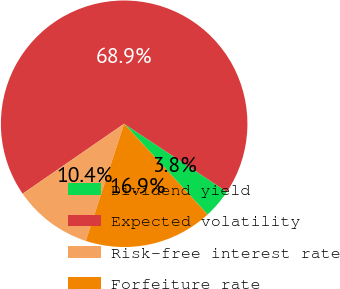<chart> <loc_0><loc_0><loc_500><loc_500><pie_chart><fcel>Dividend yield<fcel>Expected volatility<fcel>Risk-free interest rate<fcel>Forfeiture rate<nl><fcel>3.85%<fcel>68.92%<fcel>10.36%<fcel>16.87%<nl></chart> 